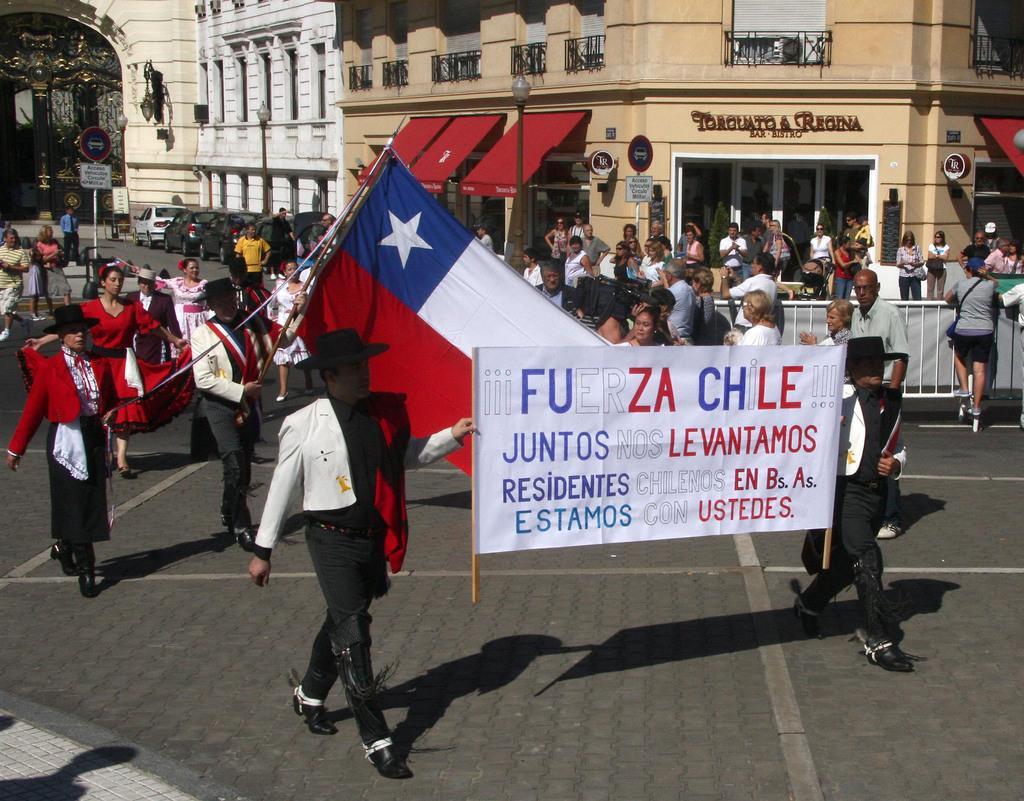In one or two sentences, can you explain what this image depicts? In this image we can see a group of persons and among them few people are holding objects. There is a banner and flag in the image and in the middle of the image we can see a barrier. Behind the persons we can see a few buildings and vehicles. 